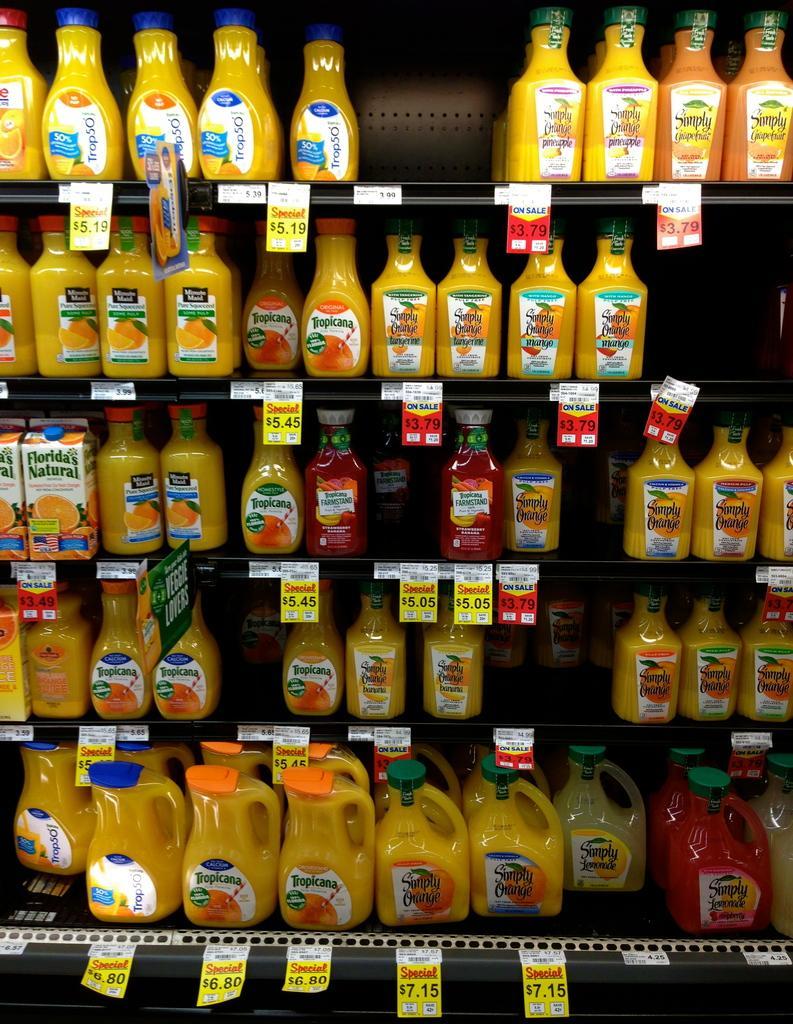How would you summarize this image in a sentence or two? In this image I can see a rack in which few bottles are arranged in an order. 